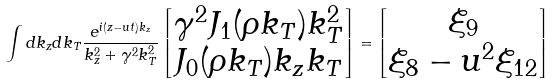<formula> <loc_0><loc_0><loc_500><loc_500>\int d k _ { z } d k _ { T } \frac { e ^ { i ( z - u t ) k _ { z } } } { k _ { z } ^ { 2 } + \gamma ^ { 2 } k _ { T } ^ { 2 } } \begin{bmatrix} \gamma ^ { 2 } J _ { 1 } ( \rho k _ { T } ) k _ { T } ^ { 2 } \\ J _ { 0 } ( \rho k _ { T } ) k _ { z } k _ { T } \end{bmatrix} = \begin{bmatrix} \xi _ { 9 } \\ \xi _ { 8 } - u ^ { 2 } \xi _ { 1 2 } \end{bmatrix}</formula> 